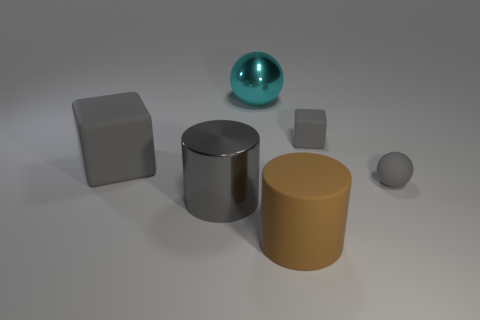Is the number of cylinders that are in front of the cyan shiny ball less than the number of rubber cylinders to the left of the big gray matte cube?
Ensure brevity in your answer.  No. There is a shiny thing to the left of the large cyan object to the left of the brown matte object; what is its shape?
Ensure brevity in your answer.  Cylinder. How many other objects are there of the same material as the big gray block?
Provide a short and direct response. 3. Is the number of tiny balls greater than the number of large metallic blocks?
Offer a terse response. Yes. There is a gray thing that is behind the matte cube in front of the small matte thing that is to the left of the gray matte sphere; what size is it?
Your response must be concise. Small. There is a cyan object; is its size the same as the gray matte object on the left side of the big brown rubber object?
Provide a short and direct response. Yes. Are there fewer cylinders that are to the right of the tiny cube than green balls?
Your answer should be very brief. No. How many big metallic cylinders are the same color as the matte sphere?
Offer a terse response. 1. Is the number of tiny gray spheres less than the number of big brown blocks?
Ensure brevity in your answer.  No. Does the big cyan sphere have the same material as the gray cylinder?
Offer a very short reply. Yes. 